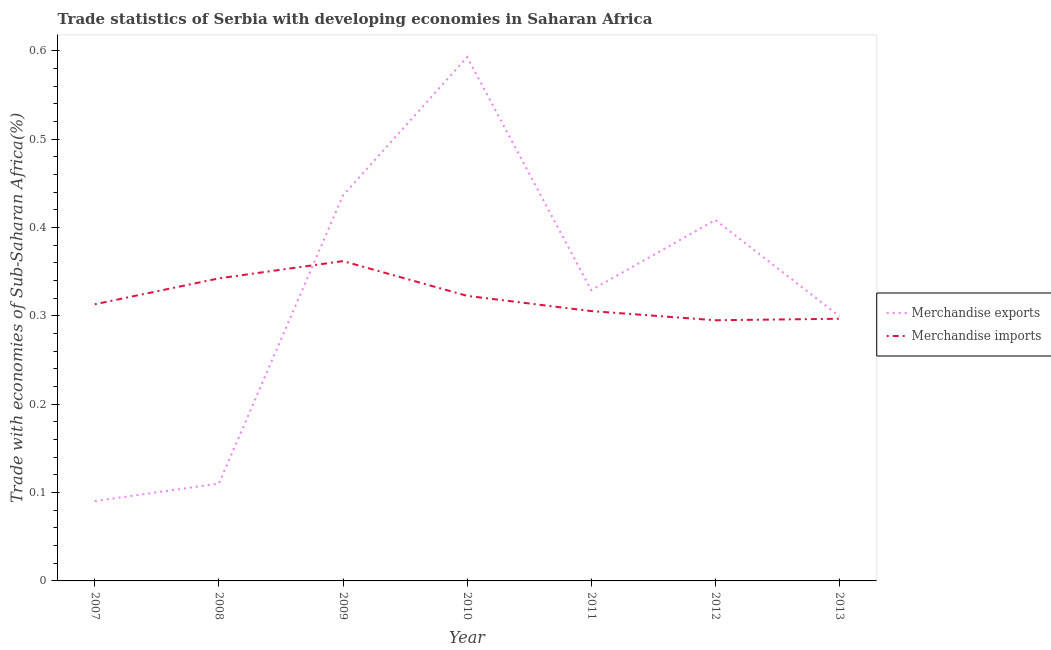How many different coloured lines are there?
Your answer should be very brief. 2. What is the merchandise imports in 2011?
Provide a succinct answer. 0.31. Across all years, what is the maximum merchandise imports?
Give a very brief answer. 0.36. Across all years, what is the minimum merchandise exports?
Make the answer very short. 0.09. In which year was the merchandise exports minimum?
Offer a very short reply. 2007. What is the total merchandise imports in the graph?
Provide a short and direct response. 2.24. What is the difference between the merchandise exports in 2009 and that in 2013?
Provide a short and direct response. 0.14. What is the difference between the merchandise imports in 2011 and the merchandise exports in 2009?
Your answer should be very brief. -0.13. What is the average merchandise exports per year?
Provide a succinct answer. 0.32. In the year 2010, what is the difference between the merchandise imports and merchandise exports?
Make the answer very short. -0.27. What is the ratio of the merchandise imports in 2007 to that in 2009?
Provide a succinct answer. 0.86. Is the difference between the merchandise imports in 2007 and 2012 greater than the difference between the merchandise exports in 2007 and 2012?
Ensure brevity in your answer.  Yes. What is the difference between the highest and the second highest merchandise imports?
Give a very brief answer. 0.02. What is the difference between the highest and the lowest merchandise exports?
Offer a terse response. 0.5. Is the sum of the merchandise imports in 2007 and 2010 greater than the maximum merchandise exports across all years?
Keep it short and to the point. Yes. What is the difference between two consecutive major ticks on the Y-axis?
Offer a very short reply. 0.1. Are the values on the major ticks of Y-axis written in scientific E-notation?
Provide a succinct answer. No. Does the graph contain any zero values?
Your response must be concise. No. Does the graph contain grids?
Your response must be concise. No. How are the legend labels stacked?
Offer a terse response. Vertical. What is the title of the graph?
Your answer should be compact. Trade statistics of Serbia with developing economies in Saharan Africa. What is the label or title of the Y-axis?
Make the answer very short. Trade with economies of Sub-Saharan Africa(%). What is the Trade with economies of Sub-Saharan Africa(%) of Merchandise exports in 2007?
Ensure brevity in your answer.  0.09. What is the Trade with economies of Sub-Saharan Africa(%) of Merchandise imports in 2007?
Give a very brief answer. 0.31. What is the Trade with economies of Sub-Saharan Africa(%) of Merchandise exports in 2008?
Give a very brief answer. 0.11. What is the Trade with economies of Sub-Saharan Africa(%) of Merchandise imports in 2008?
Make the answer very short. 0.34. What is the Trade with economies of Sub-Saharan Africa(%) in Merchandise exports in 2009?
Provide a succinct answer. 0.44. What is the Trade with economies of Sub-Saharan Africa(%) of Merchandise imports in 2009?
Your response must be concise. 0.36. What is the Trade with economies of Sub-Saharan Africa(%) of Merchandise exports in 2010?
Offer a terse response. 0.59. What is the Trade with economies of Sub-Saharan Africa(%) of Merchandise imports in 2010?
Ensure brevity in your answer.  0.32. What is the Trade with economies of Sub-Saharan Africa(%) in Merchandise exports in 2011?
Provide a short and direct response. 0.33. What is the Trade with economies of Sub-Saharan Africa(%) in Merchandise imports in 2011?
Provide a succinct answer. 0.31. What is the Trade with economies of Sub-Saharan Africa(%) in Merchandise exports in 2012?
Make the answer very short. 0.41. What is the Trade with economies of Sub-Saharan Africa(%) in Merchandise imports in 2012?
Keep it short and to the point. 0.29. What is the Trade with economies of Sub-Saharan Africa(%) of Merchandise exports in 2013?
Provide a short and direct response. 0.3. What is the Trade with economies of Sub-Saharan Africa(%) of Merchandise imports in 2013?
Give a very brief answer. 0.3. Across all years, what is the maximum Trade with economies of Sub-Saharan Africa(%) in Merchandise exports?
Your response must be concise. 0.59. Across all years, what is the maximum Trade with economies of Sub-Saharan Africa(%) of Merchandise imports?
Make the answer very short. 0.36. Across all years, what is the minimum Trade with economies of Sub-Saharan Africa(%) in Merchandise exports?
Your answer should be very brief. 0.09. Across all years, what is the minimum Trade with economies of Sub-Saharan Africa(%) of Merchandise imports?
Your answer should be compact. 0.29. What is the total Trade with economies of Sub-Saharan Africa(%) in Merchandise exports in the graph?
Keep it short and to the point. 2.27. What is the total Trade with economies of Sub-Saharan Africa(%) of Merchandise imports in the graph?
Your answer should be compact. 2.24. What is the difference between the Trade with economies of Sub-Saharan Africa(%) in Merchandise exports in 2007 and that in 2008?
Keep it short and to the point. -0.02. What is the difference between the Trade with economies of Sub-Saharan Africa(%) of Merchandise imports in 2007 and that in 2008?
Your response must be concise. -0.03. What is the difference between the Trade with economies of Sub-Saharan Africa(%) of Merchandise exports in 2007 and that in 2009?
Provide a succinct answer. -0.35. What is the difference between the Trade with economies of Sub-Saharan Africa(%) of Merchandise imports in 2007 and that in 2009?
Provide a succinct answer. -0.05. What is the difference between the Trade with economies of Sub-Saharan Africa(%) of Merchandise exports in 2007 and that in 2010?
Make the answer very short. -0.5. What is the difference between the Trade with economies of Sub-Saharan Africa(%) in Merchandise imports in 2007 and that in 2010?
Your answer should be very brief. -0.01. What is the difference between the Trade with economies of Sub-Saharan Africa(%) of Merchandise exports in 2007 and that in 2011?
Offer a terse response. -0.24. What is the difference between the Trade with economies of Sub-Saharan Africa(%) of Merchandise imports in 2007 and that in 2011?
Provide a succinct answer. 0.01. What is the difference between the Trade with economies of Sub-Saharan Africa(%) in Merchandise exports in 2007 and that in 2012?
Keep it short and to the point. -0.32. What is the difference between the Trade with economies of Sub-Saharan Africa(%) of Merchandise imports in 2007 and that in 2012?
Ensure brevity in your answer.  0.02. What is the difference between the Trade with economies of Sub-Saharan Africa(%) of Merchandise exports in 2007 and that in 2013?
Give a very brief answer. -0.21. What is the difference between the Trade with economies of Sub-Saharan Africa(%) in Merchandise imports in 2007 and that in 2013?
Provide a succinct answer. 0.02. What is the difference between the Trade with economies of Sub-Saharan Africa(%) of Merchandise exports in 2008 and that in 2009?
Ensure brevity in your answer.  -0.33. What is the difference between the Trade with economies of Sub-Saharan Africa(%) in Merchandise imports in 2008 and that in 2009?
Make the answer very short. -0.02. What is the difference between the Trade with economies of Sub-Saharan Africa(%) of Merchandise exports in 2008 and that in 2010?
Your answer should be compact. -0.48. What is the difference between the Trade with economies of Sub-Saharan Africa(%) in Merchandise imports in 2008 and that in 2010?
Your answer should be compact. 0.02. What is the difference between the Trade with economies of Sub-Saharan Africa(%) of Merchandise exports in 2008 and that in 2011?
Your answer should be very brief. -0.22. What is the difference between the Trade with economies of Sub-Saharan Africa(%) of Merchandise imports in 2008 and that in 2011?
Ensure brevity in your answer.  0.04. What is the difference between the Trade with economies of Sub-Saharan Africa(%) in Merchandise exports in 2008 and that in 2012?
Provide a short and direct response. -0.3. What is the difference between the Trade with economies of Sub-Saharan Africa(%) of Merchandise imports in 2008 and that in 2012?
Offer a terse response. 0.05. What is the difference between the Trade with economies of Sub-Saharan Africa(%) in Merchandise exports in 2008 and that in 2013?
Your answer should be very brief. -0.19. What is the difference between the Trade with economies of Sub-Saharan Africa(%) of Merchandise imports in 2008 and that in 2013?
Make the answer very short. 0.05. What is the difference between the Trade with economies of Sub-Saharan Africa(%) of Merchandise exports in 2009 and that in 2010?
Your answer should be very brief. -0.16. What is the difference between the Trade with economies of Sub-Saharan Africa(%) in Merchandise imports in 2009 and that in 2010?
Your response must be concise. 0.04. What is the difference between the Trade with economies of Sub-Saharan Africa(%) in Merchandise exports in 2009 and that in 2011?
Give a very brief answer. 0.11. What is the difference between the Trade with economies of Sub-Saharan Africa(%) in Merchandise imports in 2009 and that in 2011?
Offer a terse response. 0.06. What is the difference between the Trade with economies of Sub-Saharan Africa(%) in Merchandise exports in 2009 and that in 2012?
Your response must be concise. 0.03. What is the difference between the Trade with economies of Sub-Saharan Africa(%) of Merchandise imports in 2009 and that in 2012?
Provide a succinct answer. 0.07. What is the difference between the Trade with economies of Sub-Saharan Africa(%) in Merchandise exports in 2009 and that in 2013?
Make the answer very short. 0.14. What is the difference between the Trade with economies of Sub-Saharan Africa(%) of Merchandise imports in 2009 and that in 2013?
Give a very brief answer. 0.07. What is the difference between the Trade with economies of Sub-Saharan Africa(%) in Merchandise exports in 2010 and that in 2011?
Give a very brief answer. 0.26. What is the difference between the Trade with economies of Sub-Saharan Africa(%) in Merchandise imports in 2010 and that in 2011?
Offer a terse response. 0.02. What is the difference between the Trade with economies of Sub-Saharan Africa(%) of Merchandise exports in 2010 and that in 2012?
Your answer should be very brief. 0.18. What is the difference between the Trade with economies of Sub-Saharan Africa(%) in Merchandise imports in 2010 and that in 2012?
Provide a succinct answer. 0.03. What is the difference between the Trade with economies of Sub-Saharan Africa(%) in Merchandise exports in 2010 and that in 2013?
Your answer should be compact. 0.29. What is the difference between the Trade with economies of Sub-Saharan Africa(%) in Merchandise imports in 2010 and that in 2013?
Provide a succinct answer. 0.03. What is the difference between the Trade with economies of Sub-Saharan Africa(%) in Merchandise exports in 2011 and that in 2012?
Give a very brief answer. -0.08. What is the difference between the Trade with economies of Sub-Saharan Africa(%) in Merchandise imports in 2011 and that in 2012?
Give a very brief answer. 0.01. What is the difference between the Trade with economies of Sub-Saharan Africa(%) in Merchandise exports in 2011 and that in 2013?
Give a very brief answer. 0.03. What is the difference between the Trade with economies of Sub-Saharan Africa(%) of Merchandise imports in 2011 and that in 2013?
Make the answer very short. 0.01. What is the difference between the Trade with economies of Sub-Saharan Africa(%) in Merchandise exports in 2012 and that in 2013?
Your response must be concise. 0.11. What is the difference between the Trade with economies of Sub-Saharan Africa(%) of Merchandise imports in 2012 and that in 2013?
Keep it short and to the point. -0. What is the difference between the Trade with economies of Sub-Saharan Africa(%) of Merchandise exports in 2007 and the Trade with economies of Sub-Saharan Africa(%) of Merchandise imports in 2008?
Provide a short and direct response. -0.25. What is the difference between the Trade with economies of Sub-Saharan Africa(%) in Merchandise exports in 2007 and the Trade with economies of Sub-Saharan Africa(%) in Merchandise imports in 2009?
Provide a succinct answer. -0.27. What is the difference between the Trade with economies of Sub-Saharan Africa(%) of Merchandise exports in 2007 and the Trade with economies of Sub-Saharan Africa(%) of Merchandise imports in 2010?
Offer a terse response. -0.23. What is the difference between the Trade with economies of Sub-Saharan Africa(%) in Merchandise exports in 2007 and the Trade with economies of Sub-Saharan Africa(%) in Merchandise imports in 2011?
Give a very brief answer. -0.21. What is the difference between the Trade with economies of Sub-Saharan Africa(%) in Merchandise exports in 2007 and the Trade with economies of Sub-Saharan Africa(%) in Merchandise imports in 2012?
Keep it short and to the point. -0.2. What is the difference between the Trade with economies of Sub-Saharan Africa(%) in Merchandise exports in 2007 and the Trade with economies of Sub-Saharan Africa(%) in Merchandise imports in 2013?
Keep it short and to the point. -0.21. What is the difference between the Trade with economies of Sub-Saharan Africa(%) in Merchandise exports in 2008 and the Trade with economies of Sub-Saharan Africa(%) in Merchandise imports in 2009?
Provide a short and direct response. -0.25. What is the difference between the Trade with economies of Sub-Saharan Africa(%) in Merchandise exports in 2008 and the Trade with economies of Sub-Saharan Africa(%) in Merchandise imports in 2010?
Your answer should be very brief. -0.21. What is the difference between the Trade with economies of Sub-Saharan Africa(%) of Merchandise exports in 2008 and the Trade with economies of Sub-Saharan Africa(%) of Merchandise imports in 2011?
Give a very brief answer. -0.2. What is the difference between the Trade with economies of Sub-Saharan Africa(%) of Merchandise exports in 2008 and the Trade with economies of Sub-Saharan Africa(%) of Merchandise imports in 2012?
Ensure brevity in your answer.  -0.18. What is the difference between the Trade with economies of Sub-Saharan Africa(%) in Merchandise exports in 2008 and the Trade with economies of Sub-Saharan Africa(%) in Merchandise imports in 2013?
Your answer should be compact. -0.19. What is the difference between the Trade with economies of Sub-Saharan Africa(%) of Merchandise exports in 2009 and the Trade with economies of Sub-Saharan Africa(%) of Merchandise imports in 2010?
Your response must be concise. 0.11. What is the difference between the Trade with economies of Sub-Saharan Africa(%) of Merchandise exports in 2009 and the Trade with economies of Sub-Saharan Africa(%) of Merchandise imports in 2011?
Provide a succinct answer. 0.13. What is the difference between the Trade with economies of Sub-Saharan Africa(%) in Merchandise exports in 2009 and the Trade with economies of Sub-Saharan Africa(%) in Merchandise imports in 2012?
Offer a terse response. 0.14. What is the difference between the Trade with economies of Sub-Saharan Africa(%) of Merchandise exports in 2009 and the Trade with economies of Sub-Saharan Africa(%) of Merchandise imports in 2013?
Your answer should be very brief. 0.14. What is the difference between the Trade with economies of Sub-Saharan Africa(%) in Merchandise exports in 2010 and the Trade with economies of Sub-Saharan Africa(%) in Merchandise imports in 2011?
Provide a succinct answer. 0.29. What is the difference between the Trade with economies of Sub-Saharan Africa(%) in Merchandise exports in 2010 and the Trade with economies of Sub-Saharan Africa(%) in Merchandise imports in 2012?
Your response must be concise. 0.3. What is the difference between the Trade with economies of Sub-Saharan Africa(%) in Merchandise exports in 2010 and the Trade with economies of Sub-Saharan Africa(%) in Merchandise imports in 2013?
Offer a terse response. 0.3. What is the difference between the Trade with economies of Sub-Saharan Africa(%) in Merchandise exports in 2011 and the Trade with economies of Sub-Saharan Africa(%) in Merchandise imports in 2012?
Your answer should be compact. 0.03. What is the difference between the Trade with economies of Sub-Saharan Africa(%) of Merchandise exports in 2011 and the Trade with economies of Sub-Saharan Africa(%) of Merchandise imports in 2013?
Offer a terse response. 0.03. What is the difference between the Trade with economies of Sub-Saharan Africa(%) in Merchandise exports in 2012 and the Trade with economies of Sub-Saharan Africa(%) in Merchandise imports in 2013?
Your answer should be compact. 0.11. What is the average Trade with economies of Sub-Saharan Africa(%) in Merchandise exports per year?
Provide a short and direct response. 0.32. What is the average Trade with economies of Sub-Saharan Africa(%) in Merchandise imports per year?
Your answer should be compact. 0.32. In the year 2007, what is the difference between the Trade with economies of Sub-Saharan Africa(%) of Merchandise exports and Trade with economies of Sub-Saharan Africa(%) of Merchandise imports?
Give a very brief answer. -0.22. In the year 2008, what is the difference between the Trade with economies of Sub-Saharan Africa(%) of Merchandise exports and Trade with economies of Sub-Saharan Africa(%) of Merchandise imports?
Your response must be concise. -0.23. In the year 2009, what is the difference between the Trade with economies of Sub-Saharan Africa(%) of Merchandise exports and Trade with economies of Sub-Saharan Africa(%) of Merchandise imports?
Give a very brief answer. 0.07. In the year 2010, what is the difference between the Trade with economies of Sub-Saharan Africa(%) of Merchandise exports and Trade with economies of Sub-Saharan Africa(%) of Merchandise imports?
Make the answer very short. 0.27. In the year 2011, what is the difference between the Trade with economies of Sub-Saharan Africa(%) of Merchandise exports and Trade with economies of Sub-Saharan Africa(%) of Merchandise imports?
Provide a succinct answer. 0.02. In the year 2012, what is the difference between the Trade with economies of Sub-Saharan Africa(%) in Merchandise exports and Trade with economies of Sub-Saharan Africa(%) in Merchandise imports?
Keep it short and to the point. 0.11. In the year 2013, what is the difference between the Trade with economies of Sub-Saharan Africa(%) of Merchandise exports and Trade with economies of Sub-Saharan Africa(%) of Merchandise imports?
Provide a short and direct response. 0. What is the ratio of the Trade with economies of Sub-Saharan Africa(%) in Merchandise exports in 2007 to that in 2008?
Provide a succinct answer. 0.82. What is the ratio of the Trade with economies of Sub-Saharan Africa(%) of Merchandise imports in 2007 to that in 2008?
Offer a very short reply. 0.91. What is the ratio of the Trade with economies of Sub-Saharan Africa(%) of Merchandise exports in 2007 to that in 2009?
Provide a short and direct response. 0.21. What is the ratio of the Trade with economies of Sub-Saharan Africa(%) of Merchandise imports in 2007 to that in 2009?
Your answer should be compact. 0.86. What is the ratio of the Trade with economies of Sub-Saharan Africa(%) of Merchandise exports in 2007 to that in 2010?
Provide a short and direct response. 0.15. What is the ratio of the Trade with economies of Sub-Saharan Africa(%) in Merchandise imports in 2007 to that in 2010?
Make the answer very short. 0.97. What is the ratio of the Trade with economies of Sub-Saharan Africa(%) of Merchandise exports in 2007 to that in 2011?
Keep it short and to the point. 0.27. What is the ratio of the Trade with economies of Sub-Saharan Africa(%) in Merchandise imports in 2007 to that in 2011?
Ensure brevity in your answer.  1.03. What is the ratio of the Trade with economies of Sub-Saharan Africa(%) of Merchandise exports in 2007 to that in 2012?
Provide a succinct answer. 0.22. What is the ratio of the Trade with economies of Sub-Saharan Africa(%) in Merchandise imports in 2007 to that in 2012?
Your answer should be very brief. 1.06. What is the ratio of the Trade with economies of Sub-Saharan Africa(%) in Merchandise exports in 2007 to that in 2013?
Give a very brief answer. 0.3. What is the ratio of the Trade with economies of Sub-Saharan Africa(%) in Merchandise imports in 2007 to that in 2013?
Give a very brief answer. 1.06. What is the ratio of the Trade with economies of Sub-Saharan Africa(%) of Merchandise exports in 2008 to that in 2009?
Offer a very short reply. 0.25. What is the ratio of the Trade with economies of Sub-Saharan Africa(%) in Merchandise imports in 2008 to that in 2009?
Keep it short and to the point. 0.95. What is the ratio of the Trade with economies of Sub-Saharan Africa(%) in Merchandise exports in 2008 to that in 2010?
Your response must be concise. 0.19. What is the ratio of the Trade with economies of Sub-Saharan Africa(%) of Merchandise imports in 2008 to that in 2010?
Offer a very short reply. 1.06. What is the ratio of the Trade with economies of Sub-Saharan Africa(%) of Merchandise exports in 2008 to that in 2011?
Offer a very short reply. 0.33. What is the ratio of the Trade with economies of Sub-Saharan Africa(%) of Merchandise imports in 2008 to that in 2011?
Your answer should be very brief. 1.12. What is the ratio of the Trade with economies of Sub-Saharan Africa(%) of Merchandise exports in 2008 to that in 2012?
Keep it short and to the point. 0.27. What is the ratio of the Trade with economies of Sub-Saharan Africa(%) of Merchandise imports in 2008 to that in 2012?
Keep it short and to the point. 1.16. What is the ratio of the Trade with economies of Sub-Saharan Africa(%) of Merchandise exports in 2008 to that in 2013?
Keep it short and to the point. 0.37. What is the ratio of the Trade with economies of Sub-Saharan Africa(%) in Merchandise imports in 2008 to that in 2013?
Ensure brevity in your answer.  1.15. What is the ratio of the Trade with economies of Sub-Saharan Africa(%) of Merchandise exports in 2009 to that in 2010?
Your response must be concise. 0.74. What is the ratio of the Trade with economies of Sub-Saharan Africa(%) in Merchandise imports in 2009 to that in 2010?
Offer a terse response. 1.12. What is the ratio of the Trade with economies of Sub-Saharan Africa(%) in Merchandise exports in 2009 to that in 2011?
Your response must be concise. 1.33. What is the ratio of the Trade with economies of Sub-Saharan Africa(%) of Merchandise imports in 2009 to that in 2011?
Offer a terse response. 1.19. What is the ratio of the Trade with economies of Sub-Saharan Africa(%) in Merchandise exports in 2009 to that in 2012?
Keep it short and to the point. 1.07. What is the ratio of the Trade with economies of Sub-Saharan Africa(%) of Merchandise imports in 2009 to that in 2012?
Keep it short and to the point. 1.23. What is the ratio of the Trade with economies of Sub-Saharan Africa(%) in Merchandise exports in 2009 to that in 2013?
Your response must be concise. 1.46. What is the ratio of the Trade with economies of Sub-Saharan Africa(%) in Merchandise imports in 2009 to that in 2013?
Your answer should be very brief. 1.22. What is the ratio of the Trade with economies of Sub-Saharan Africa(%) in Merchandise exports in 2010 to that in 2011?
Ensure brevity in your answer.  1.8. What is the ratio of the Trade with economies of Sub-Saharan Africa(%) of Merchandise imports in 2010 to that in 2011?
Your answer should be compact. 1.06. What is the ratio of the Trade with economies of Sub-Saharan Africa(%) in Merchandise exports in 2010 to that in 2012?
Make the answer very short. 1.45. What is the ratio of the Trade with economies of Sub-Saharan Africa(%) of Merchandise imports in 2010 to that in 2012?
Provide a short and direct response. 1.09. What is the ratio of the Trade with economies of Sub-Saharan Africa(%) in Merchandise exports in 2010 to that in 2013?
Provide a succinct answer. 1.98. What is the ratio of the Trade with economies of Sub-Saharan Africa(%) in Merchandise imports in 2010 to that in 2013?
Provide a short and direct response. 1.09. What is the ratio of the Trade with economies of Sub-Saharan Africa(%) in Merchandise exports in 2011 to that in 2012?
Your answer should be compact. 0.81. What is the ratio of the Trade with economies of Sub-Saharan Africa(%) in Merchandise imports in 2011 to that in 2012?
Provide a short and direct response. 1.04. What is the ratio of the Trade with economies of Sub-Saharan Africa(%) in Merchandise exports in 2011 to that in 2013?
Ensure brevity in your answer.  1.1. What is the ratio of the Trade with economies of Sub-Saharan Africa(%) of Merchandise imports in 2011 to that in 2013?
Provide a short and direct response. 1.03. What is the ratio of the Trade with economies of Sub-Saharan Africa(%) of Merchandise exports in 2012 to that in 2013?
Provide a succinct answer. 1.36. What is the ratio of the Trade with economies of Sub-Saharan Africa(%) in Merchandise imports in 2012 to that in 2013?
Provide a short and direct response. 0.99. What is the difference between the highest and the second highest Trade with economies of Sub-Saharan Africa(%) in Merchandise exports?
Keep it short and to the point. 0.16. What is the difference between the highest and the second highest Trade with economies of Sub-Saharan Africa(%) of Merchandise imports?
Make the answer very short. 0.02. What is the difference between the highest and the lowest Trade with economies of Sub-Saharan Africa(%) of Merchandise exports?
Your response must be concise. 0.5. What is the difference between the highest and the lowest Trade with economies of Sub-Saharan Africa(%) of Merchandise imports?
Provide a short and direct response. 0.07. 